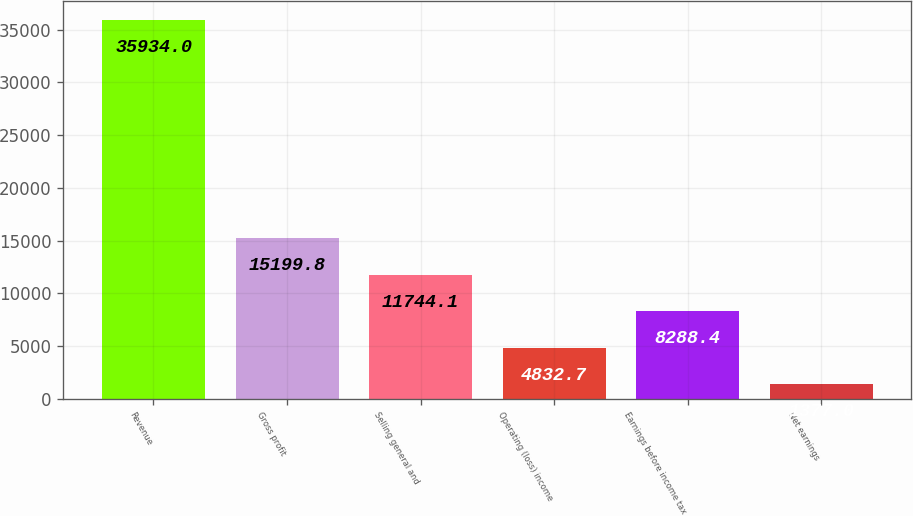<chart> <loc_0><loc_0><loc_500><loc_500><bar_chart><fcel>Revenue<fcel>Gross profit<fcel>Selling general and<fcel>Operating (loss) income<fcel>Earnings before income tax<fcel>Net earnings<nl><fcel>35934<fcel>15199.8<fcel>11744.1<fcel>4832.7<fcel>8288.4<fcel>1377<nl></chart> 